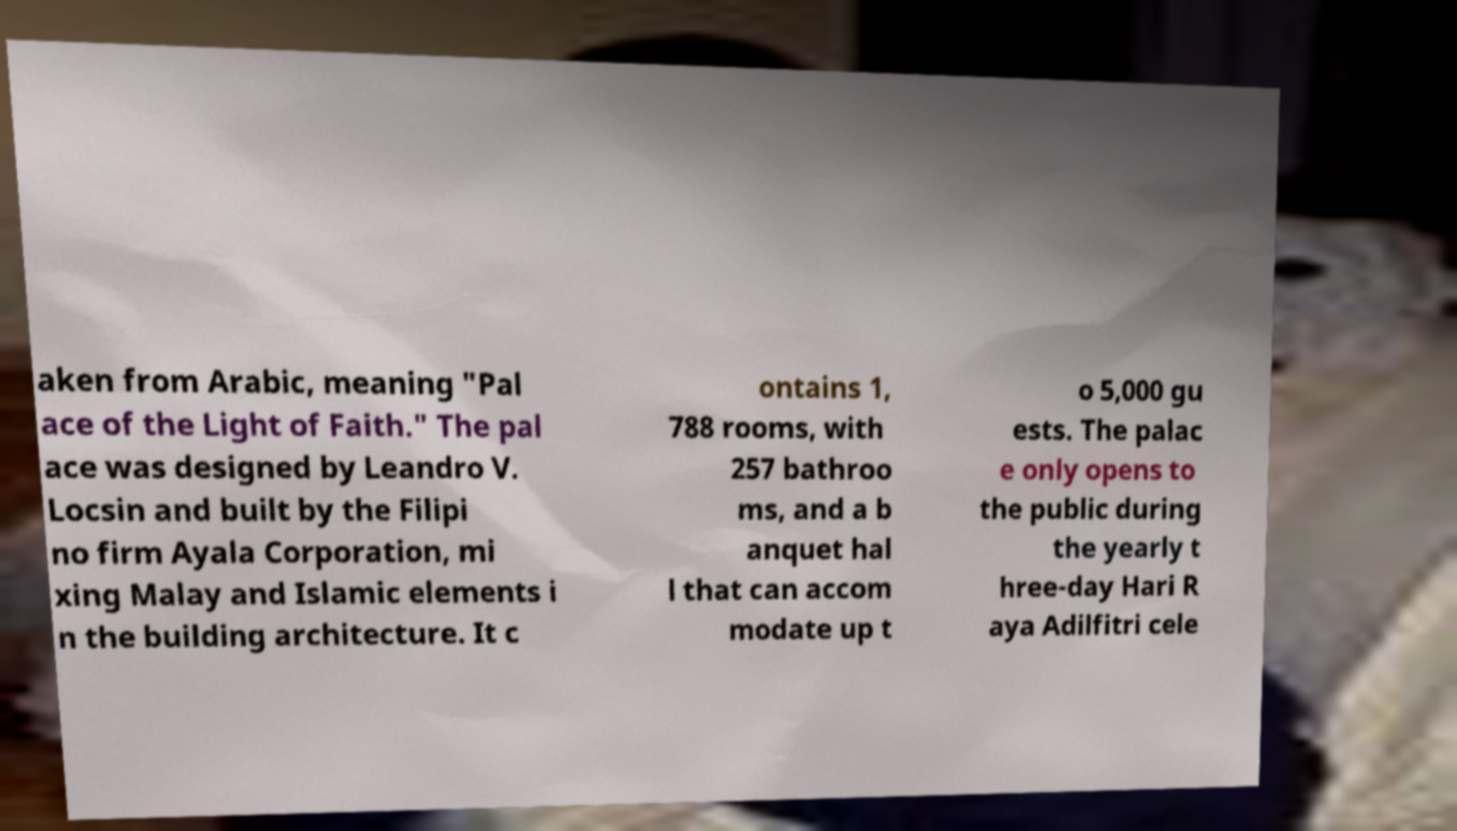What messages or text are displayed in this image? I need them in a readable, typed format. aken from Arabic, meaning "Pal ace of the Light of Faith." The pal ace was designed by Leandro V. Locsin and built by the Filipi no firm Ayala Corporation, mi xing Malay and Islamic elements i n the building architecture. It c ontains 1, 788 rooms, with 257 bathroo ms, and a b anquet hal l that can accom modate up t o 5,000 gu ests. The palac e only opens to the public during the yearly t hree-day Hari R aya Adilfitri cele 